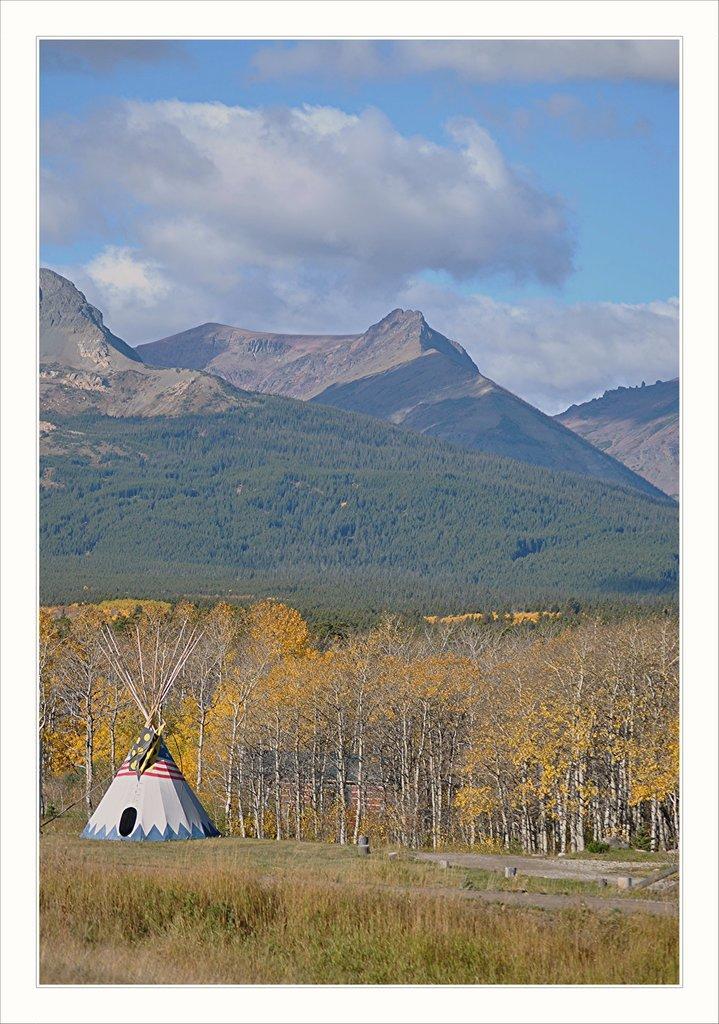In one or two sentences, can you explain what this image depicts? This image is taken outdoors. At the top of the image there is a sky with clouds. At the bottom of the image there is a ground with grass on it. In the background there are a few hills and there are many trees and plants. In the middle of the image there are a few trees and there is a tent. 